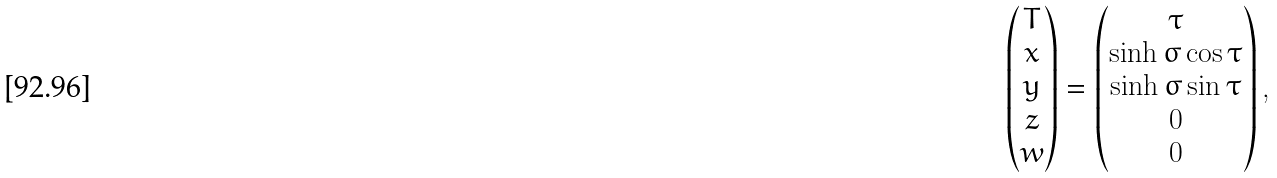<formula> <loc_0><loc_0><loc_500><loc_500>\begin{pmatrix} T \\ x \\ y \\ z \\ w \end{pmatrix} = \begin{pmatrix} { \tau } \\ { \sinh \sigma \cos \tau } \\ { \sinh \sigma \sin \tau } \\ 0 \\ 0 \end{pmatrix} ,</formula> 